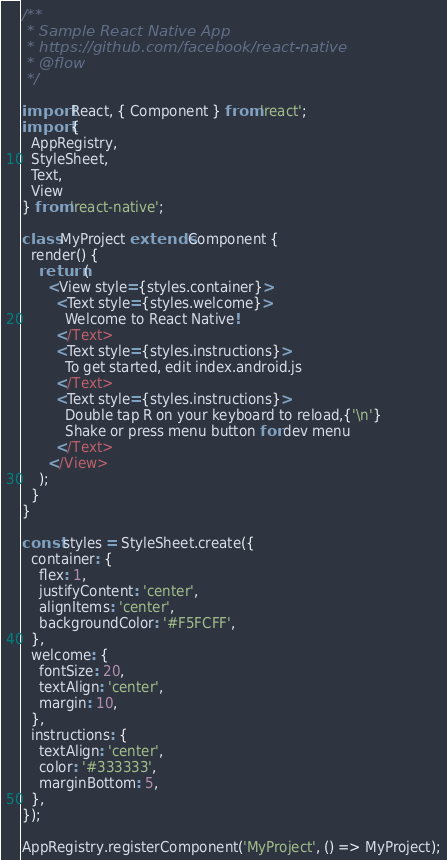<code> <loc_0><loc_0><loc_500><loc_500><_JavaScript_>/**
 * Sample React Native App
 * https://github.com/facebook/react-native
 * @flow
 */

import React, { Component } from 'react';
import {
  AppRegistry,
  StyleSheet,
  Text,
  View
} from 'react-native';

class MyProject extends Component {
  render() {
    return (
      <View style={styles.container}>
        <Text style={styles.welcome}>
          Welcome to React Native!
        </Text>
        <Text style={styles.instructions}>
          To get started, edit index.android.js
        </Text>
        <Text style={styles.instructions}>
          Double tap R on your keyboard to reload,{'\n'}
          Shake or press menu button for dev menu
        </Text>
      </View>
    );
  }
}

const styles = StyleSheet.create({
  container: {
    flex: 1,
    justifyContent: 'center',
    alignItems: 'center',
    backgroundColor: '#F5FCFF',
  },
  welcome: {
    fontSize: 20,
    textAlign: 'center',
    margin: 10,
  },
  instructions: {
    textAlign: 'center',
    color: '#333333',
    marginBottom: 5,
  },
});

AppRegistry.registerComponent('MyProject', () => MyProject);
</code> 